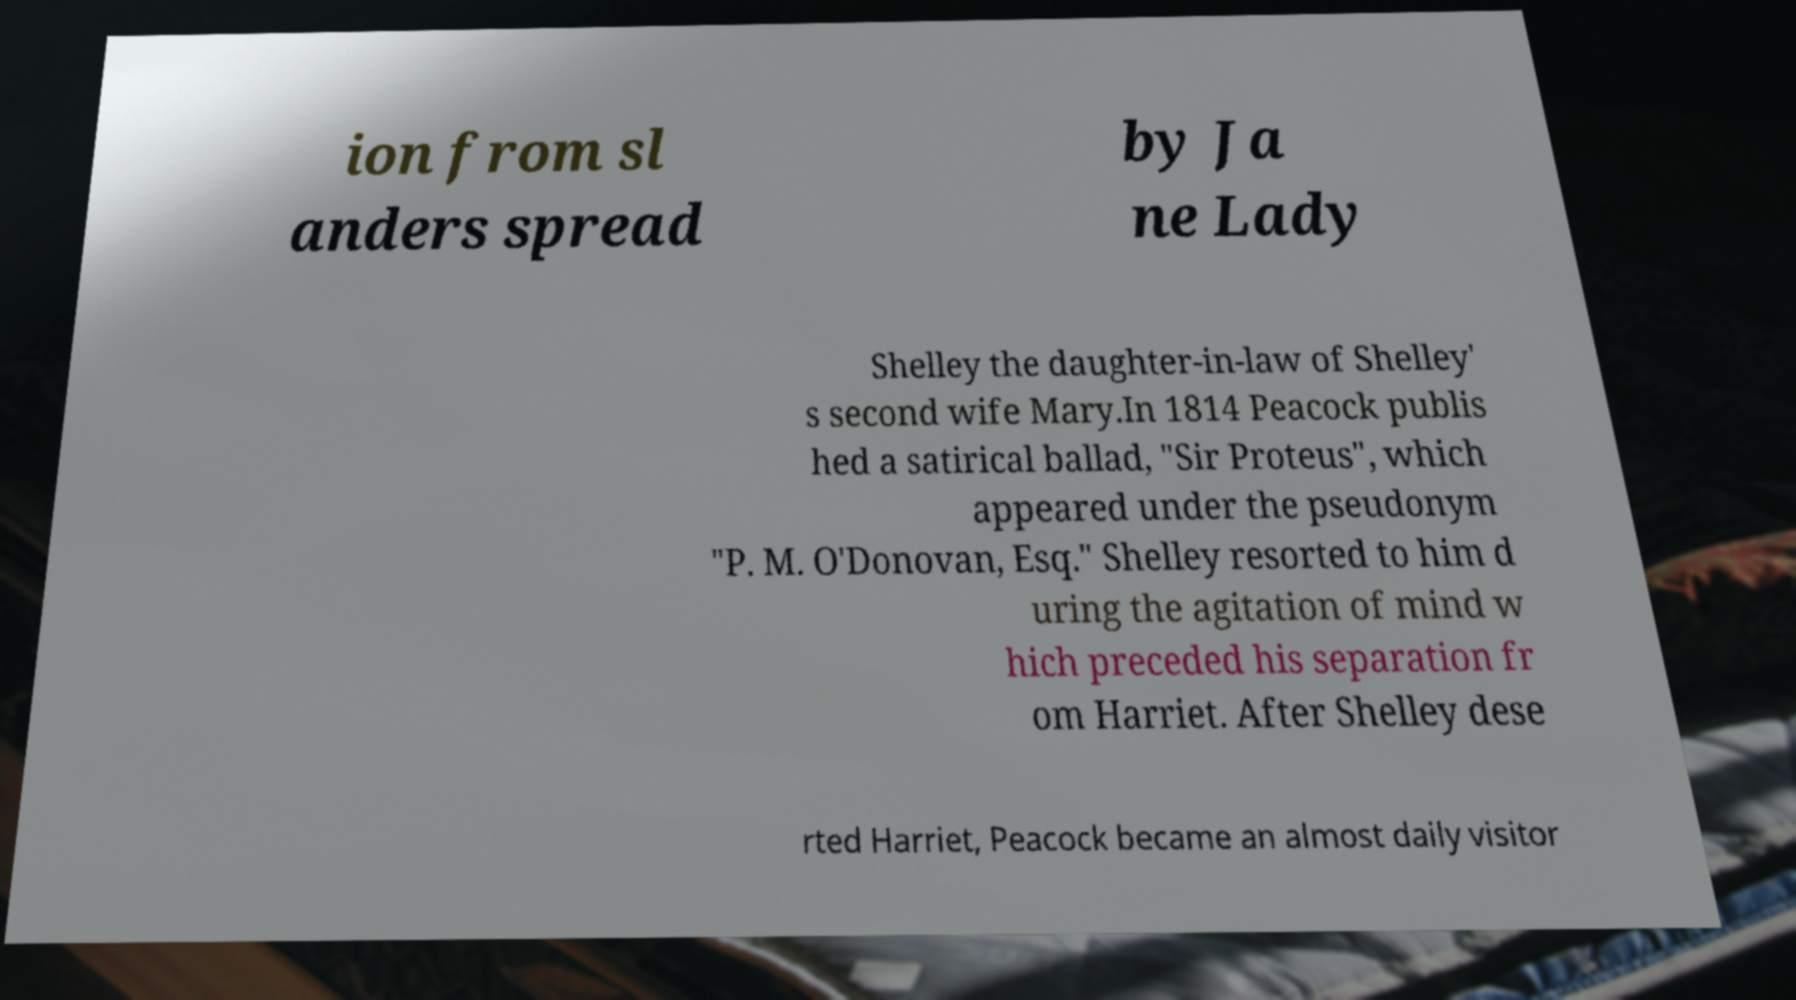Please identify and transcribe the text found in this image. ion from sl anders spread by Ja ne Lady Shelley the daughter-in-law of Shelley' s second wife Mary.In 1814 Peacock publis hed a satirical ballad, "Sir Proteus", which appeared under the pseudonym "P. M. O'Donovan, Esq." Shelley resorted to him d uring the agitation of mind w hich preceded his separation fr om Harriet. After Shelley dese rted Harriet, Peacock became an almost daily visitor 